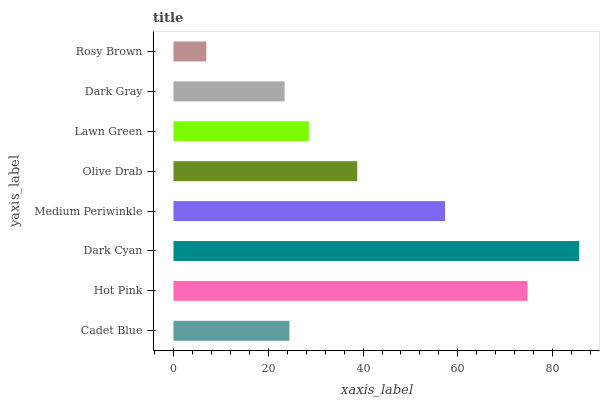Is Rosy Brown the minimum?
Answer yes or no. Yes. Is Dark Cyan the maximum?
Answer yes or no. Yes. Is Hot Pink the minimum?
Answer yes or no. No. Is Hot Pink the maximum?
Answer yes or no. No. Is Hot Pink greater than Cadet Blue?
Answer yes or no. Yes. Is Cadet Blue less than Hot Pink?
Answer yes or no. Yes. Is Cadet Blue greater than Hot Pink?
Answer yes or no. No. Is Hot Pink less than Cadet Blue?
Answer yes or no. No. Is Olive Drab the high median?
Answer yes or no. Yes. Is Lawn Green the low median?
Answer yes or no. Yes. Is Lawn Green the high median?
Answer yes or no. No. Is Hot Pink the low median?
Answer yes or no. No. 